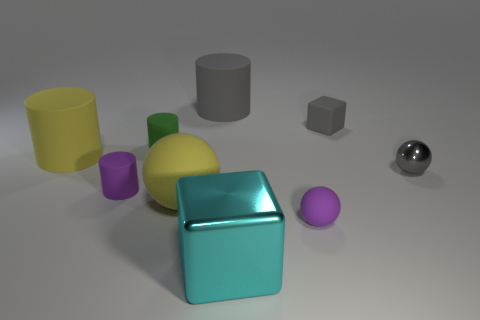Are there any large matte cylinders of the same color as the metal sphere?
Provide a succinct answer. Yes. What shape is the large matte object that is the same color as the tiny metal ball?
Ensure brevity in your answer.  Cylinder. There is a object that is on the right side of the purple matte ball and in front of the small green rubber cylinder; what is its shape?
Make the answer very short. Sphere. The large yellow object to the right of the purple thing left of the tiny purple ball is made of what material?
Keep it short and to the point. Rubber. Does the small purple object left of the big cyan metallic object have the same material as the yellow cylinder?
Provide a short and direct response. Yes. How big is the matte cylinder behind the tiny green thing?
Offer a very short reply. Large. There is a rubber cylinder that is in front of the tiny gray metal thing; is there a big cylinder to the right of it?
Offer a terse response. Yes. There is a big cylinder that is behind the tiny gray block; is its color the same as the block behind the big yellow cylinder?
Provide a succinct answer. Yes. The big ball has what color?
Give a very brief answer. Yellow. Is there anything else that is the same color as the big cube?
Your response must be concise. No. 